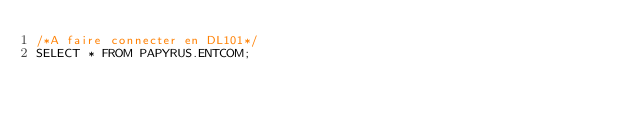Convert code to text. <code><loc_0><loc_0><loc_500><loc_500><_SQL_>/*A faire connecter en DL101*/
SELECT * FROM PAPYRUS.ENTCOM;</code> 